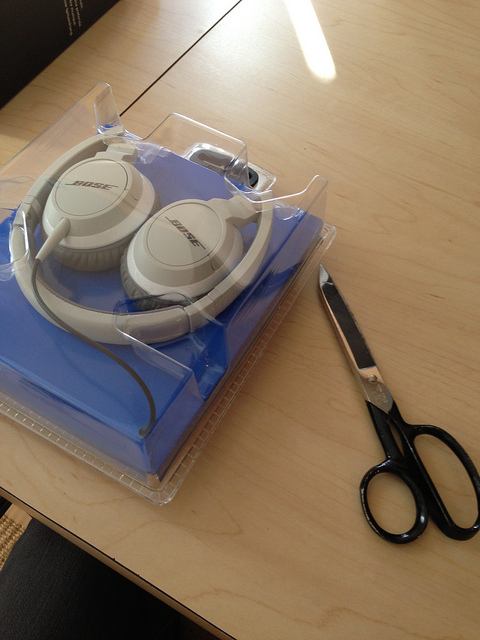Identify and read out the text in this image. BOSE BOSE 